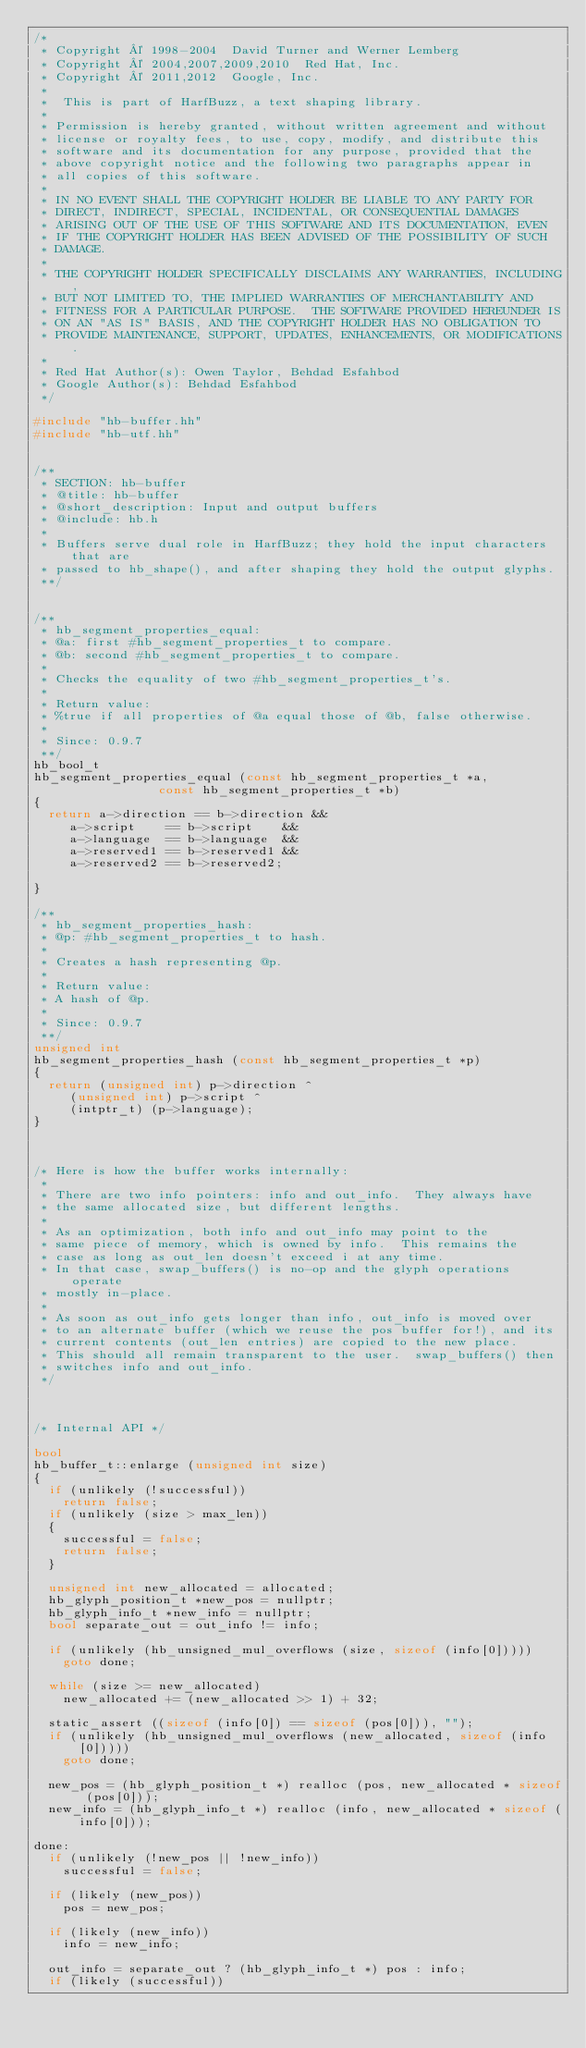<code> <loc_0><loc_0><loc_500><loc_500><_C++_>/*
 * Copyright © 1998-2004  David Turner and Werner Lemberg
 * Copyright © 2004,2007,2009,2010  Red Hat, Inc.
 * Copyright © 2011,2012  Google, Inc.
 *
 *  This is part of HarfBuzz, a text shaping library.
 *
 * Permission is hereby granted, without written agreement and without
 * license or royalty fees, to use, copy, modify, and distribute this
 * software and its documentation for any purpose, provided that the
 * above copyright notice and the following two paragraphs appear in
 * all copies of this software.
 *
 * IN NO EVENT SHALL THE COPYRIGHT HOLDER BE LIABLE TO ANY PARTY FOR
 * DIRECT, INDIRECT, SPECIAL, INCIDENTAL, OR CONSEQUENTIAL DAMAGES
 * ARISING OUT OF THE USE OF THIS SOFTWARE AND ITS DOCUMENTATION, EVEN
 * IF THE COPYRIGHT HOLDER HAS BEEN ADVISED OF THE POSSIBILITY OF SUCH
 * DAMAGE.
 *
 * THE COPYRIGHT HOLDER SPECIFICALLY DISCLAIMS ANY WARRANTIES, INCLUDING,
 * BUT NOT LIMITED TO, THE IMPLIED WARRANTIES OF MERCHANTABILITY AND
 * FITNESS FOR A PARTICULAR PURPOSE.  THE SOFTWARE PROVIDED HEREUNDER IS
 * ON AN "AS IS" BASIS, AND THE COPYRIGHT HOLDER HAS NO OBLIGATION TO
 * PROVIDE MAINTENANCE, SUPPORT, UPDATES, ENHANCEMENTS, OR MODIFICATIONS.
 *
 * Red Hat Author(s): Owen Taylor, Behdad Esfahbod
 * Google Author(s): Behdad Esfahbod
 */

#include "hb-buffer.hh"
#include "hb-utf.hh"


/**
 * SECTION: hb-buffer
 * @title: hb-buffer
 * @short_description: Input and output buffers
 * @include: hb.h
 *
 * Buffers serve dual role in HarfBuzz; they hold the input characters that are
 * passed to hb_shape(), and after shaping they hold the output glyphs.
 **/


/**
 * hb_segment_properties_equal:
 * @a: first #hb_segment_properties_t to compare.
 * @b: second #hb_segment_properties_t to compare.
 *
 * Checks the equality of two #hb_segment_properties_t's.
 *
 * Return value:
 * %true if all properties of @a equal those of @b, false otherwise.
 *
 * Since: 0.9.7
 **/
hb_bool_t
hb_segment_properties_equal (const hb_segment_properties_t *a,
			     const hb_segment_properties_t *b)
{
  return a->direction == b->direction &&
	 a->script    == b->script    &&
	 a->language  == b->language  &&
	 a->reserved1 == b->reserved1 &&
	 a->reserved2 == b->reserved2;

}

/**
 * hb_segment_properties_hash:
 * @p: #hb_segment_properties_t to hash.
 *
 * Creates a hash representing @p.
 *
 * Return value:
 * A hash of @p.
 *
 * Since: 0.9.7
 **/
unsigned int
hb_segment_properties_hash (const hb_segment_properties_t *p)
{
  return (unsigned int) p->direction ^
	 (unsigned int) p->script ^
	 (intptr_t) (p->language);
}



/* Here is how the buffer works internally:
 *
 * There are two info pointers: info and out_info.  They always have
 * the same allocated size, but different lengths.
 *
 * As an optimization, both info and out_info may point to the
 * same piece of memory, which is owned by info.  This remains the
 * case as long as out_len doesn't exceed i at any time.
 * In that case, swap_buffers() is no-op and the glyph operations operate
 * mostly in-place.
 *
 * As soon as out_info gets longer than info, out_info is moved over
 * to an alternate buffer (which we reuse the pos buffer for!), and its
 * current contents (out_len entries) are copied to the new place.
 * This should all remain transparent to the user.  swap_buffers() then
 * switches info and out_info.
 */



/* Internal API */

bool
hb_buffer_t::enlarge (unsigned int size)
{
  if (unlikely (!successful))
    return false;
  if (unlikely (size > max_len))
  {
    successful = false;
    return false;
  }

  unsigned int new_allocated = allocated;
  hb_glyph_position_t *new_pos = nullptr;
  hb_glyph_info_t *new_info = nullptr;
  bool separate_out = out_info != info;

  if (unlikely (hb_unsigned_mul_overflows (size, sizeof (info[0]))))
    goto done;

  while (size >= new_allocated)
    new_allocated += (new_allocated >> 1) + 32;

  static_assert ((sizeof (info[0]) == sizeof (pos[0])), "");
  if (unlikely (hb_unsigned_mul_overflows (new_allocated, sizeof (info[0]))))
    goto done;

  new_pos = (hb_glyph_position_t *) realloc (pos, new_allocated * sizeof (pos[0]));
  new_info = (hb_glyph_info_t *) realloc (info, new_allocated * sizeof (info[0]));

done:
  if (unlikely (!new_pos || !new_info))
    successful = false;

  if (likely (new_pos))
    pos = new_pos;

  if (likely (new_info))
    info = new_info;

  out_info = separate_out ? (hb_glyph_info_t *) pos : info;
  if (likely (successful))</code> 